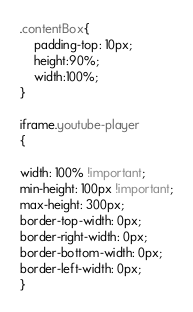Convert code to text. <code><loc_0><loc_0><loc_500><loc_500><_CSS_>
.contentBox{
	padding-top: 10px;
	height:90%;
	width:100%;
}

iframe.youtube-player
{

width: 100% !important;
min-height: 100px !important;
max-height: 300px;
border-top-width: 0px;
border-right-width: 0px;
border-bottom-width: 0px;
border-left-width: 0px;
}
</code> 